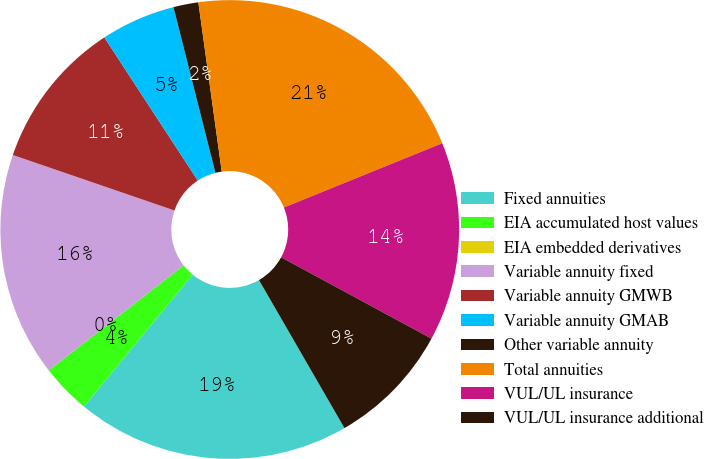<chart> <loc_0><loc_0><loc_500><loc_500><pie_chart><fcel>Fixed annuities<fcel>EIA accumulated host values<fcel>EIA embedded derivatives<fcel>Variable annuity fixed<fcel>Variable annuity GMWB<fcel>Variable annuity GMAB<fcel>Other variable annuity<fcel>Total annuities<fcel>VUL/UL insurance<fcel>VUL/UL insurance additional<nl><fcel>19.3%<fcel>3.51%<fcel>0.0%<fcel>15.79%<fcel>10.53%<fcel>5.26%<fcel>1.76%<fcel>21.05%<fcel>14.03%<fcel>8.77%<nl></chart> 